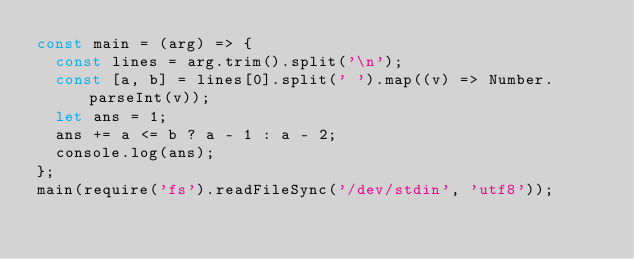Convert code to text. <code><loc_0><loc_0><loc_500><loc_500><_JavaScript_>const main = (arg) => {
  const lines = arg.trim().split('\n');
  const [a, b] = lines[0].split(' ').map((v) => Number.parseInt(v));
  let ans = 1;
  ans += a <= b ? a - 1 : a - 2;
  console.log(ans);
};
main(require('fs').readFileSync('/dev/stdin', 'utf8'));
</code> 